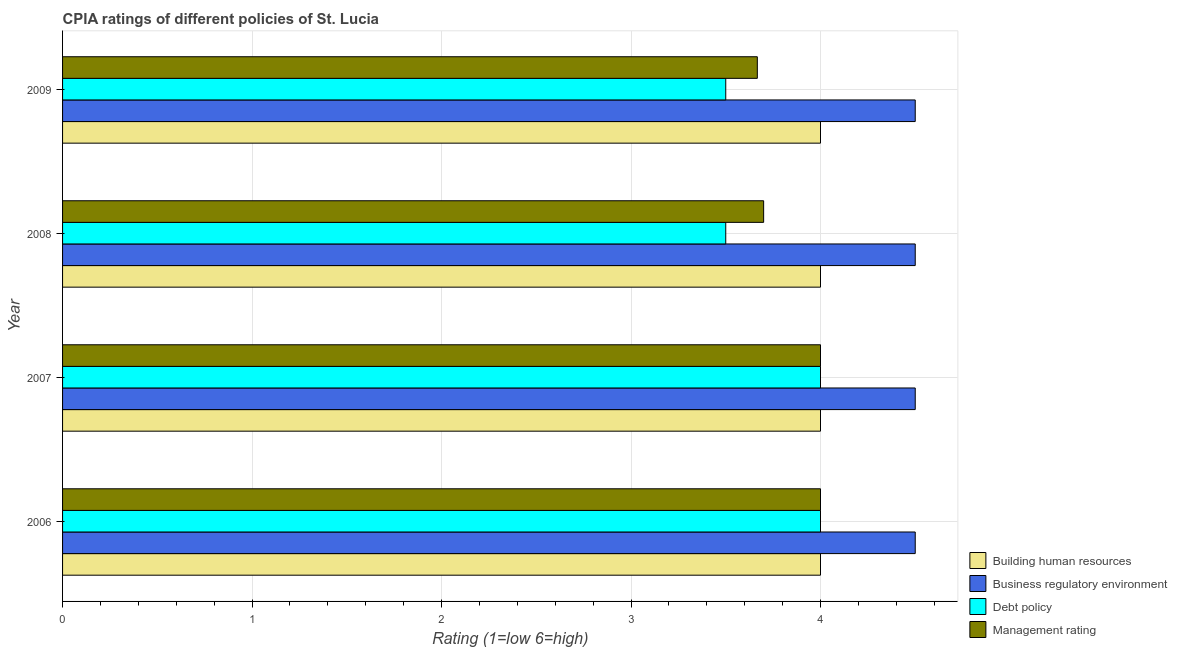How many different coloured bars are there?
Give a very brief answer. 4. How many groups of bars are there?
Offer a very short reply. 4. How many bars are there on the 1st tick from the bottom?
Offer a terse response. 4. What is the label of the 4th group of bars from the top?
Keep it short and to the point. 2006. What is the cpia rating of building human resources in 2008?
Ensure brevity in your answer.  4. Across all years, what is the minimum cpia rating of building human resources?
Ensure brevity in your answer.  4. In which year was the cpia rating of debt policy maximum?
Your answer should be compact. 2006. In which year was the cpia rating of debt policy minimum?
Your answer should be compact. 2008. What is the difference between the cpia rating of building human resources in 2007 and the cpia rating of business regulatory environment in 2006?
Your answer should be very brief. -0.5. What is the average cpia rating of building human resources per year?
Keep it short and to the point. 4. In the year 2009, what is the difference between the cpia rating of building human resources and cpia rating of business regulatory environment?
Offer a terse response. -0.5. Is the cpia rating of debt policy in 2007 less than that in 2008?
Ensure brevity in your answer.  No. Is the difference between the cpia rating of management in 2006 and 2008 greater than the difference between the cpia rating of building human resources in 2006 and 2008?
Offer a terse response. Yes. What is the difference between the highest and the lowest cpia rating of building human resources?
Your response must be concise. 0. In how many years, is the cpia rating of debt policy greater than the average cpia rating of debt policy taken over all years?
Make the answer very short. 2. Is the sum of the cpia rating of debt policy in 2008 and 2009 greater than the maximum cpia rating of management across all years?
Your response must be concise. Yes. Is it the case that in every year, the sum of the cpia rating of management and cpia rating of building human resources is greater than the sum of cpia rating of business regulatory environment and cpia rating of debt policy?
Your answer should be compact. No. What does the 1st bar from the top in 2006 represents?
Your answer should be compact. Management rating. What does the 1st bar from the bottom in 2008 represents?
Your answer should be compact. Building human resources. Is it the case that in every year, the sum of the cpia rating of building human resources and cpia rating of business regulatory environment is greater than the cpia rating of debt policy?
Ensure brevity in your answer.  Yes. How many bars are there?
Provide a short and direct response. 16. Are all the bars in the graph horizontal?
Offer a very short reply. Yes. How many years are there in the graph?
Your response must be concise. 4. What is the difference between two consecutive major ticks on the X-axis?
Provide a succinct answer. 1. Are the values on the major ticks of X-axis written in scientific E-notation?
Ensure brevity in your answer.  No. What is the title of the graph?
Offer a very short reply. CPIA ratings of different policies of St. Lucia. Does "Belgium" appear as one of the legend labels in the graph?
Ensure brevity in your answer.  No. What is the Rating (1=low 6=high) in Building human resources in 2006?
Make the answer very short. 4. What is the Rating (1=low 6=high) in Building human resources in 2007?
Your answer should be compact. 4. What is the Rating (1=low 6=high) in Management rating in 2007?
Provide a short and direct response. 4. What is the Rating (1=low 6=high) in Building human resources in 2008?
Offer a very short reply. 4. What is the Rating (1=low 6=high) of Debt policy in 2008?
Offer a terse response. 3.5. What is the Rating (1=low 6=high) of Management rating in 2008?
Your answer should be very brief. 3.7. What is the Rating (1=low 6=high) of Business regulatory environment in 2009?
Your answer should be compact. 4.5. What is the Rating (1=low 6=high) in Management rating in 2009?
Ensure brevity in your answer.  3.67. Across all years, what is the maximum Rating (1=low 6=high) of Business regulatory environment?
Provide a short and direct response. 4.5. Across all years, what is the maximum Rating (1=low 6=high) in Management rating?
Provide a succinct answer. 4. Across all years, what is the minimum Rating (1=low 6=high) of Building human resources?
Offer a very short reply. 4. Across all years, what is the minimum Rating (1=low 6=high) of Debt policy?
Provide a succinct answer. 3.5. Across all years, what is the minimum Rating (1=low 6=high) in Management rating?
Ensure brevity in your answer.  3.67. What is the total Rating (1=low 6=high) of Management rating in the graph?
Your answer should be compact. 15.37. What is the difference between the Rating (1=low 6=high) in Building human resources in 2006 and that in 2007?
Your answer should be compact. 0. What is the difference between the Rating (1=low 6=high) in Business regulatory environment in 2006 and that in 2007?
Your response must be concise. 0. What is the difference between the Rating (1=low 6=high) in Building human resources in 2006 and that in 2008?
Offer a very short reply. 0. What is the difference between the Rating (1=low 6=high) in Business regulatory environment in 2006 and that in 2008?
Your answer should be compact. 0. What is the difference between the Rating (1=low 6=high) of Debt policy in 2006 and that in 2008?
Offer a very short reply. 0.5. What is the difference between the Rating (1=low 6=high) of Management rating in 2006 and that in 2009?
Your answer should be compact. 0.33. What is the difference between the Rating (1=low 6=high) in Building human resources in 2007 and that in 2008?
Offer a very short reply. 0. What is the difference between the Rating (1=low 6=high) of Debt policy in 2007 and that in 2008?
Provide a succinct answer. 0.5. What is the difference between the Rating (1=low 6=high) in Building human resources in 2007 and that in 2009?
Ensure brevity in your answer.  0. What is the difference between the Rating (1=low 6=high) of Business regulatory environment in 2007 and that in 2009?
Your answer should be compact. 0. What is the difference between the Rating (1=low 6=high) of Management rating in 2008 and that in 2009?
Offer a very short reply. 0.03. What is the difference between the Rating (1=low 6=high) in Building human resources in 2006 and the Rating (1=low 6=high) in Business regulatory environment in 2007?
Give a very brief answer. -0.5. What is the difference between the Rating (1=low 6=high) of Debt policy in 2006 and the Rating (1=low 6=high) of Management rating in 2007?
Keep it short and to the point. 0. What is the difference between the Rating (1=low 6=high) of Building human resources in 2006 and the Rating (1=low 6=high) of Business regulatory environment in 2008?
Your response must be concise. -0.5. What is the difference between the Rating (1=low 6=high) in Building human resources in 2006 and the Rating (1=low 6=high) in Debt policy in 2008?
Make the answer very short. 0.5. What is the difference between the Rating (1=low 6=high) in Building human resources in 2006 and the Rating (1=low 6=high) in Management rating in 2008?
Your answer should be very brief. 0.3. What is the difference between the Rating (1=low 6=high) in Business regulatory environment in 2006 and the Rating (1=low 6=high) in Management rating in 2008?
Offer a very short reply. 0.8. What is the difference between the Rating (1=low 6=high) in Debt policy in 2006 and the Rating (1=low 6=high) in Management rating in 2008?
Your answer should be compact. 0.3. What is the difference between the Rating (1=low 6=high) in Building human resources in 2006 and the Rating (1=low 6=high) in Business regulatory environment in 2009?
Offer a terse response. -0.5. What is the difference between the Rating (1=low 6=high) of Business regulatory environment in 2006 and the Rating (1=low 6=high) of Management rating in 2009?
Give a very brief answer. 0.83. What is the difference between the Rating (1=low 6=high) in Debt policy in 2006 and the Rating (1=low 6=high) in Management rating in 2009?
Make the answer very short. 0.33. What is the difference between the Rating (1=low 6=high) in Building human resources in 2007 and the Rating (1=low 6=high) in Debt policy in 2008?
Your answer should be very brief. 0.5. What is the difference between the Rating (1=low 6=high) of Building human resources in 2007 and the Rating (1=low 6=high) of Management rating in 2008?
Provide a short and direct response. 0.3. What is the difference between the Rating (1=low 6=high) in Debt policy in 2007 and the Rating (1=low 6=high) in Management rating in 2008?
Your answer should be compact. 0.3. What is the difference between the Rating (1=low 6=high) in Building human resources in 2007 and the Rating (1=low 6=high) in Debt policy in 2009?
Keep it short and to the point. 0.5. What is the difference between the Rating (1=low 6=high) of Building human resources in 2007 and the Rating (1=low 6=high) of Management rating in 2009?
Offer a terse response. 0.33. What is the difference between the Rating (1=low 6=high) of Business regulatory environment in 2007 and the Rating (1=low 6=high) of Debt policy in 2009?
Your answer should be very brief. 1. What is the difference between the Rating (1=low 6=high) in Business regulatory environment in 2007 and the Rating (1=low 6=high) in Management rating in 2009?
Ensure brevity in your answer.  0.83. What is the difference between the Rating (1=low 6=high) in Building human resources in 2008 and the Rating (1=low 6=high) in Business regulatory environment in 2009?
Keep it short and to the point. -0.5. What is the difference between the Rating (1=low 6=high) in Building human resources in 2008 and the Rating (1=low 6=high) in Debt policy in 2009?
Offer a terse response. 0.5. What is the difference between the Rating (1=low 6=high) in Building human resources in 2008 and the Rating (1=low 6=high) in Management rating in 2009?
Ensure brevity in your answer.  0.33. What is the difference between the Rating (1=low 6=high) in Business regulatory environment in 2008 and the Rating (1=low 6=high) in Debt policy in 2009?
Give a very brief answer. 1. What is the average Rating (1=low 6=high) of Debt policy per year?
Ensure brevity in your answer.  3.75. What is the average Rating (1=low 6=high) of Management rating per year?
Ensure brevity in your answer.  3.84. In the year 2006, what is the difference between the Rating (1=low 6=high) in Building human resources and Rating (1=low 6=high) in Debt policy?
Your answer should be very brief. 0. In the year 2006, what is the difference between the Rating (1=low 6=high) of Business regulatory environment and Rating (1=low 6=high) of Debt policy?
Make the answer very short. 0.5. In the year 2007, what is the difference between the Rating (1=low 6=high) of Business regulatory environment and Rating (1=low 6=high) of Debt policy?
Offer a terse response. 0.5. In the year 2007, what is the difference between the Rating (1=low 6=high) of Debt policy and Rating (1=low 6=high) of Management rating?
Offer a very short reply. 0. In the year 2008, what is the difference between the Rating (1=low 6=high) of Business regulatory environment and Rating (1=low 6=high) of Debt policy?
Your response must be concise. 1. In the year 2008, what is the difference between the Rating (1=low 6=high) of Business regulatory environment and Rating (1=low 6=high) of Management rating?
Keep it short and to the point. 0.8. In the year 2008, what is the difference between the Rating (1=low 6=high) of Debt policy and Rating (1=low 6=high) of Management rating?
Your response must be concise. -0.2. In the year 2009, what is the difference between the Rating (1=low 6=high) in Building human resources and Rating (1=low 6=high) in Management rating?
Ensure brevity in your answer.  0.33. In the year 2009, what is the difference between the Rating (1=low 6=high) of Business regulatory environment and Rating (1=low 6=high) of Debt policy?
Provide a short and direct response. 1. In the year 2009, what is the difference between the Rating (1=low 6=high) of Debt policy and Rating (1=low 6=high) of Management rating?
Offer a terse response. -0.17. What is the ratio of the Rating (1=low 6=high) in Building human resources in 2006 to that in 2007?
Offer a terse response. 1. What is the ratio of the Rating (1=low 6=high) of Business regulatory environment in 2006 to that in 2008?
Your answer should be very brief. 1. What is the ratio of the Rating (1=low 6=high) in Management rating in 2006 to that in 2008?
Ensure brevity in your answer.  1.08. What is the ratio of the Rating (1=low 6=high) of Building human resources in 2006 to that in 2009?
Offer a very short reply. 1. What is the ratio of the Rating (1=low 6=high) of Debt policy in 2006 to that in 2009?
Offer a terse response. 1.14. What is the ratio of the Rating (1=low 6=high) in Management rating in 2006 to that in 2009?
Keep it short and to the point. 1.09. What is the ratio of the Rating (1=low 6=high) in Building human resources in 2007 to that in 2008?
Your response must be concise. 1. What is the ratio of the Rating (1=low 6=high) of Business regulatory environment in 2007 to that in 2008?
Ensure brevity in your answer.  1. What is the ratio of the Rating (1=low 6=high) in Management rating in 2007 to that in 2008?
Your answer should be very brief. 1.08. What is the ratio of the Rating (1=low 6=high) of Debt policy in 2008 to that in 2009?
Provide a short and direct response. 1. What is the ratio of the Rating (1=low 6=high) in Management rating in 2008 to that in 2009?
Your response must be concise. 1.01. What is the difference between the highest and the second highest Rating (1=low 6=high) in Business regulatory environment?
Offer a terse response. 0. What is the difference between the highest and the second highest Rating (1=low 6=high) in Management rating?
Ensure brevity in your answer.  0. What is the difference between the highest and the lowest Rating (1=low 6=high) of Building human resources?
Offer a very short reply. 0. What is the difference between the highest and the lowest Rating (1=low 6=high) of Business regulatory environment?
Your answer should be compact. 0. 